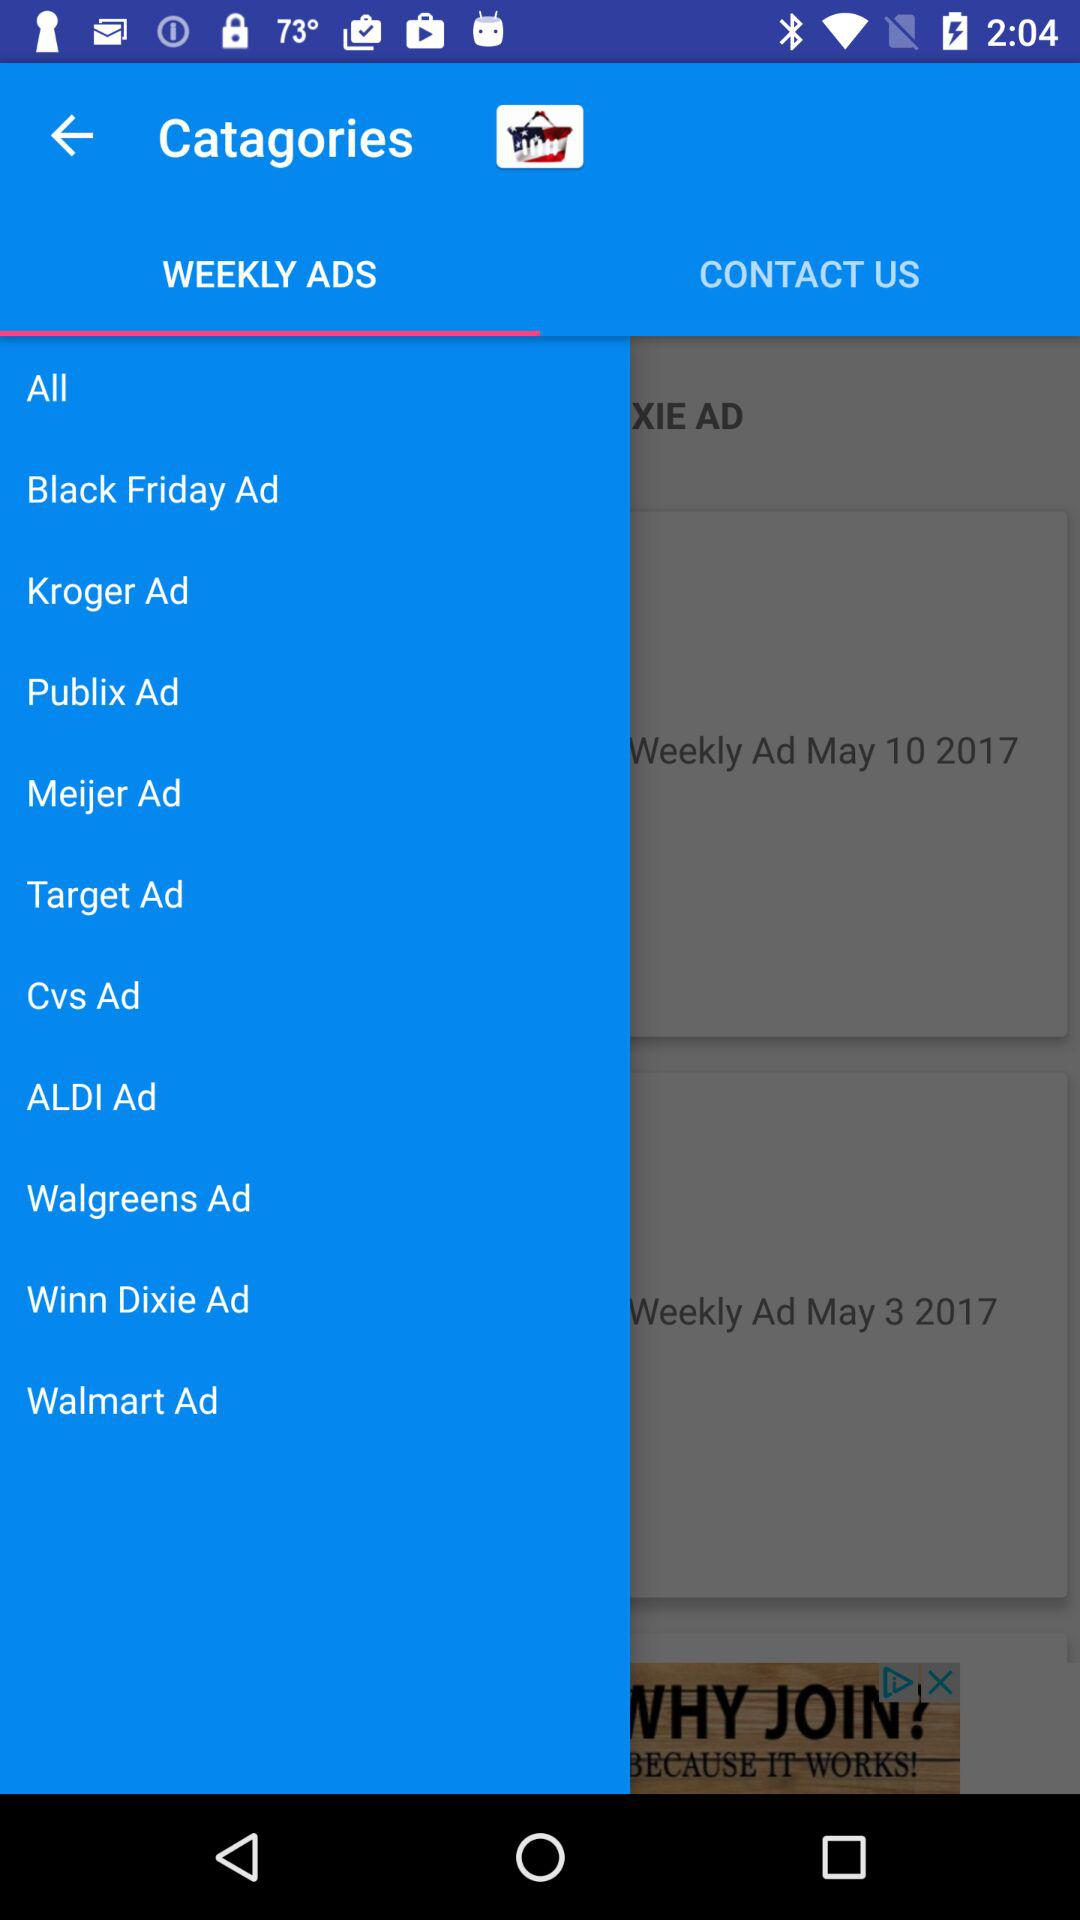Which tab has been selected? The tab that has been selected is "WEEKLY ADS". 